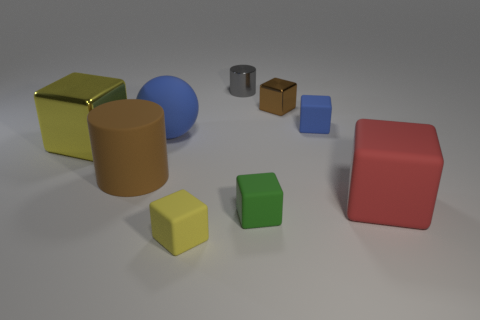There is a tiny object that is the same color as the big sphere; what material is it?
Provide a short and direct response. Rubber. There is a cylinder that is made of the same material as the small blue thing; what color is it?
Your response must be concise. Brown. Are there any other things that are the same size as the red cube?
Make the answer very short. Yes. What number of things are behind the sphere?
Provide a short and direct response. 3. There is a small block that is behind the tiny blue object; is it the same color as the big block right of the small yellow block?
Provide a short and direct response. No. What is the color of the other small metal object that is the same shape as the small yellow object?
Offer a terse response. Brown. Is there any other thing that has the same shape as the small gray metallic object?
Your answer should be compact. Yes. Do the small shiny object that is to the left of the small brown object and the brown thing left of the tiny green object have the same shape?
Your answer should be compact. Yes. There is a red rubber thing; is its size the same as the yellow block behind the red rubber object?
Make the answer very short. Yes. Is the number of big matte cylinders greater than the number of large green rubber things?
Make the answer very short. Yes. 